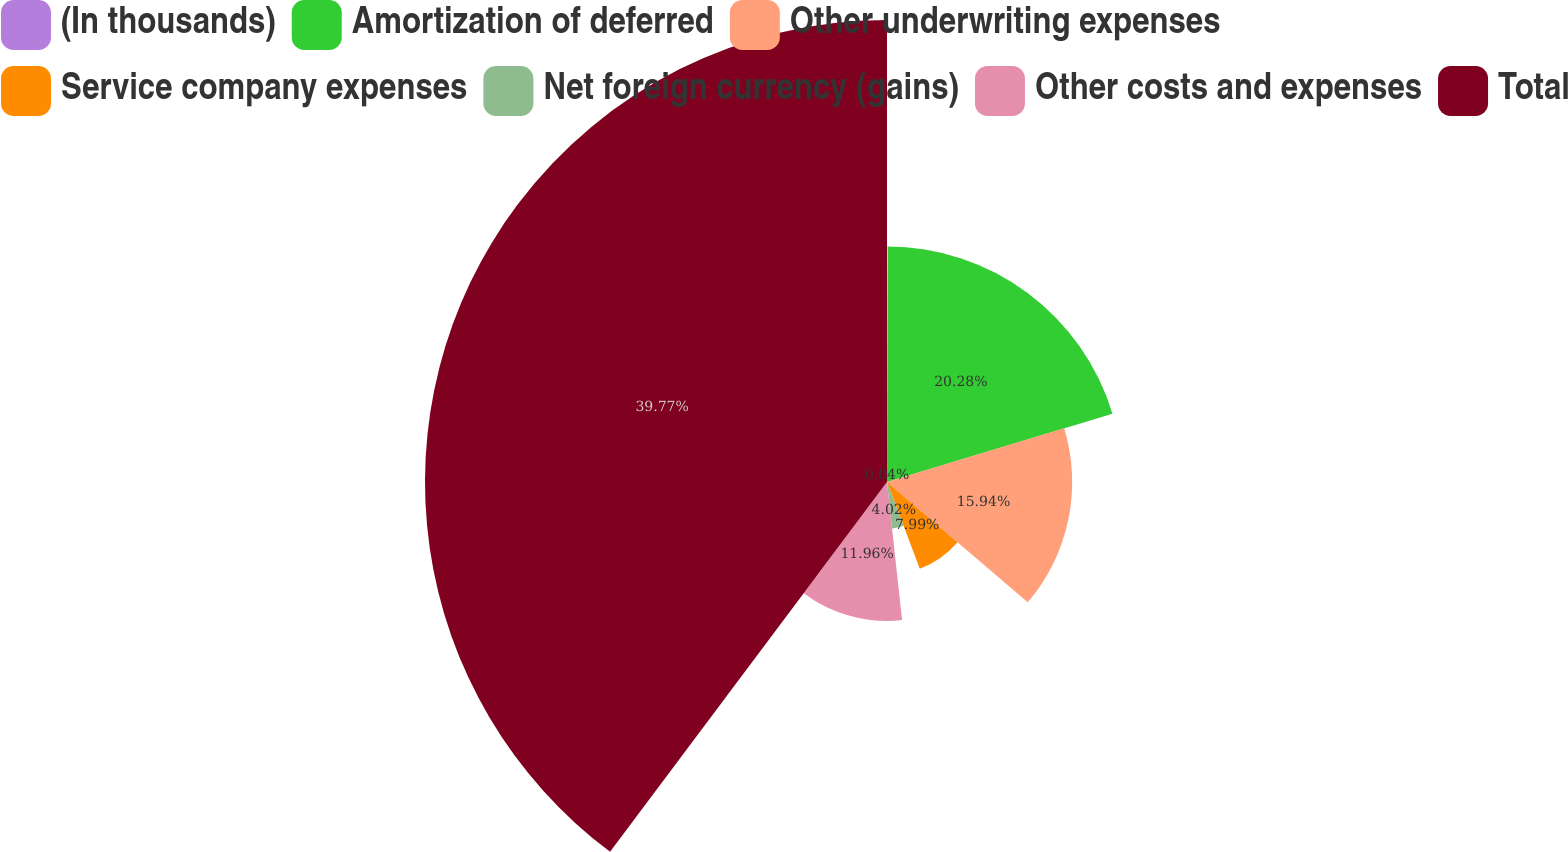Convert chart. <chart><loc_0><loc_0><loc_500><loc_500><pie_chart><fcel>(In thousands)<fcel>Amortization of deferred<fcel>Other underwriting expenses<fcel>Service company expenses<fcel>Net foreign currency (gains)<fcel>Other costs and expenses<fcel>Total<nl><fcel>0.04%<fcel>20.28%<fcel>15.94%<fcel>7.99%<fcel>4.02%<fcel>11.96%<fcel>39.77%<nl></chart> 